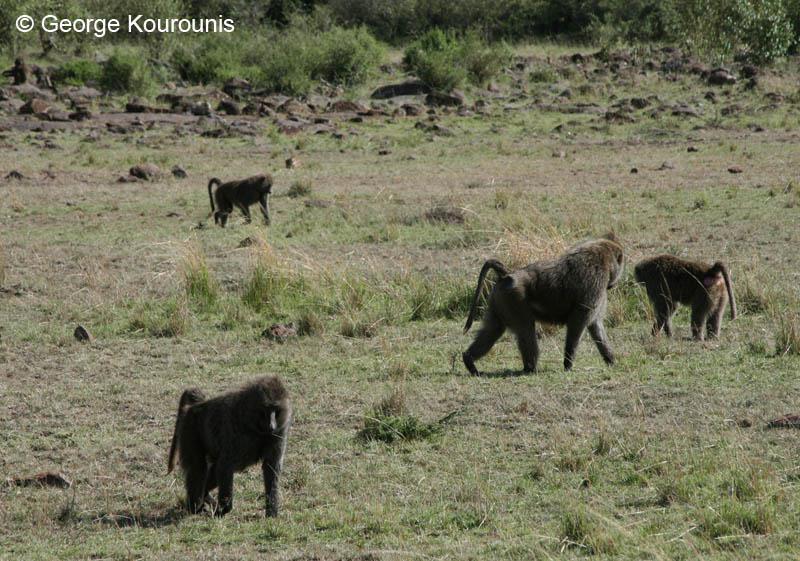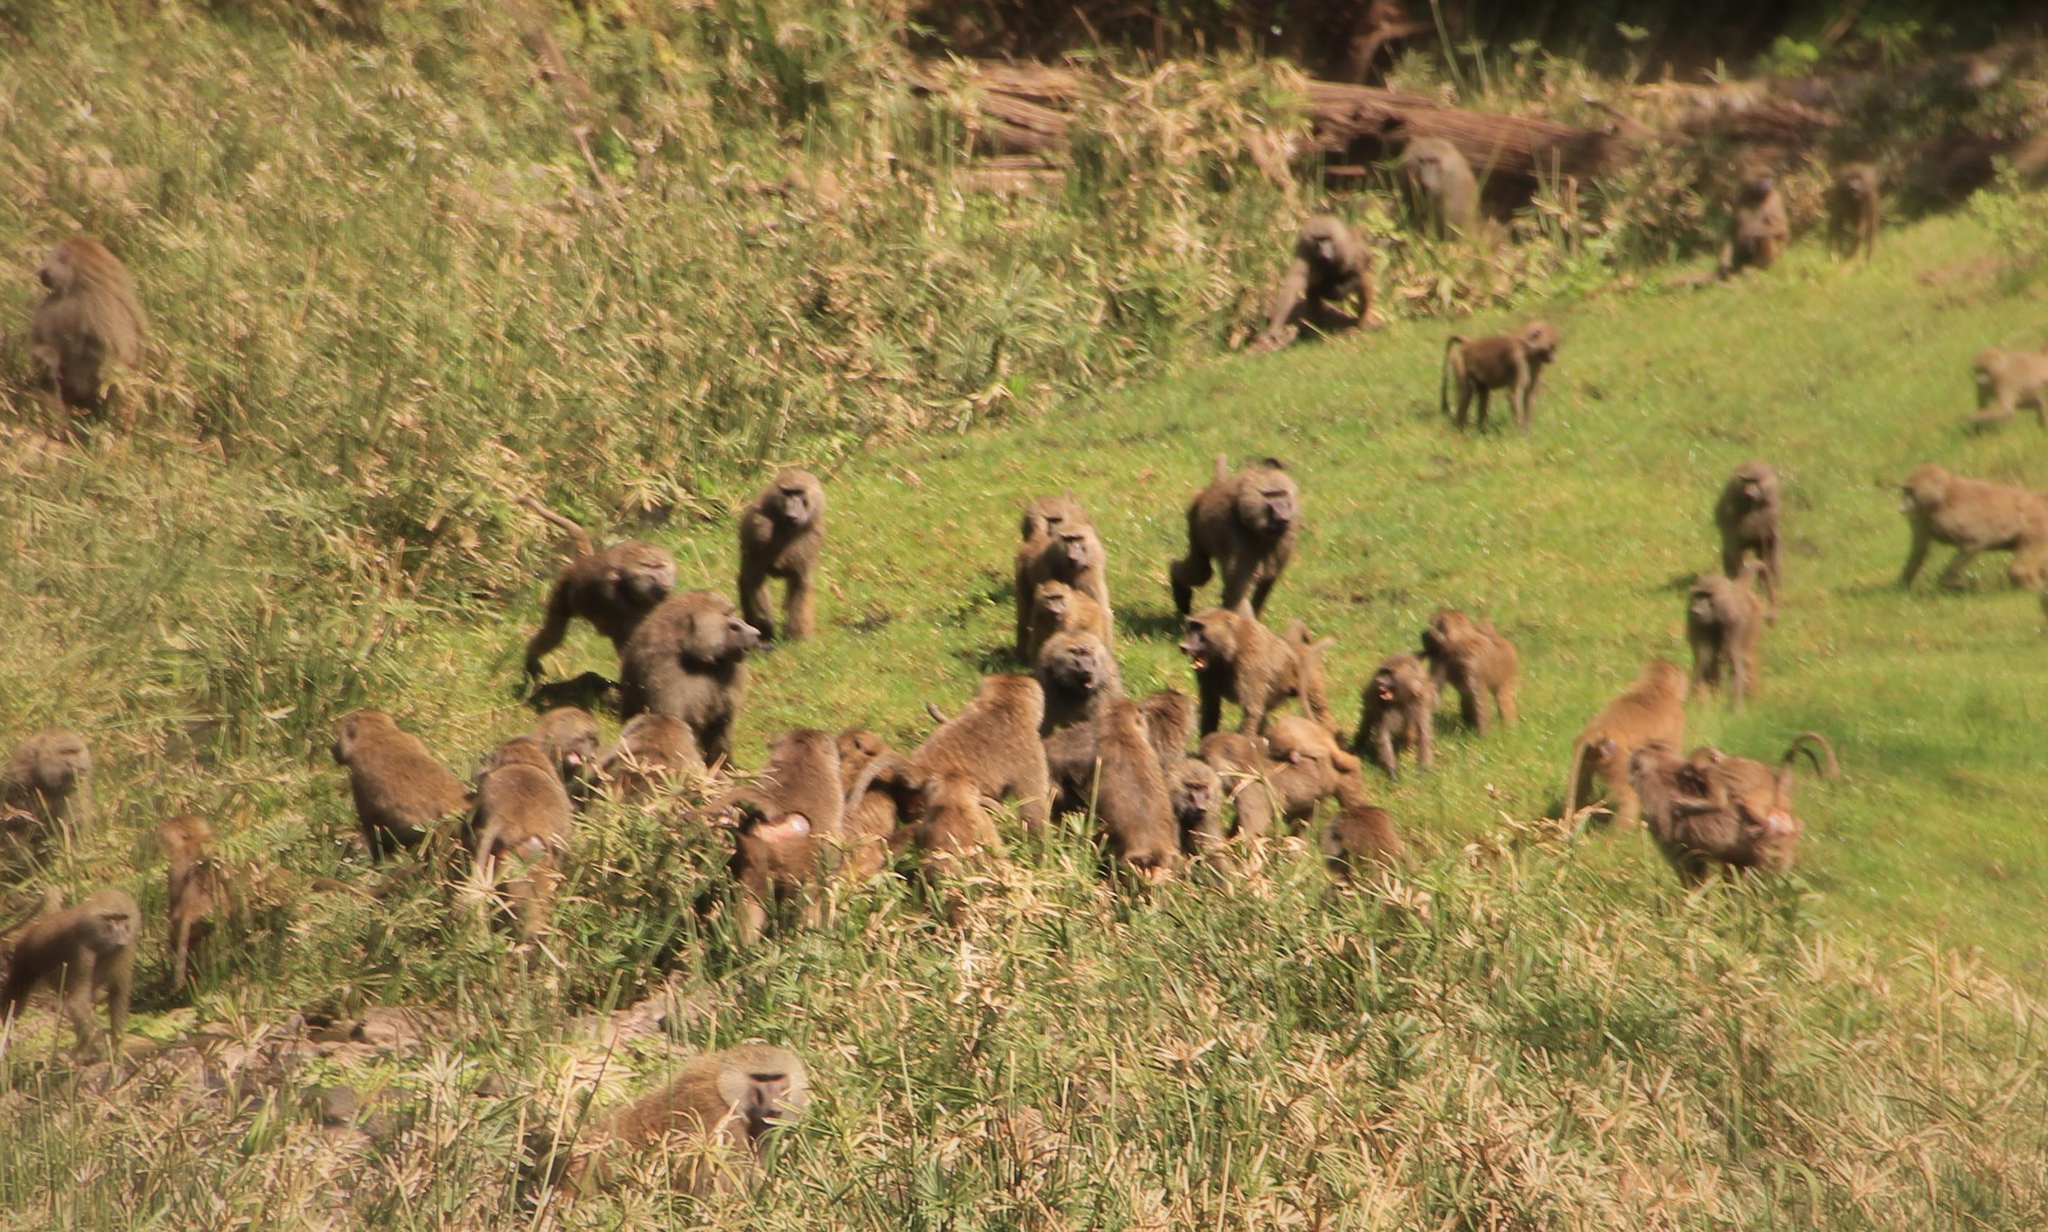The first image is the image on the left, the second image is the image on the right. Examine the images to the left and right. Is the description "There are seven lesser apes in the image to the right." accurate? Answer yes or no. No. The first image is the image on the left, the second image is the image on the right. For the images shown, is this caption "The left image contains no more than four baboons and does not contain any baby baboons." true? Answer yes or no. Yes. 